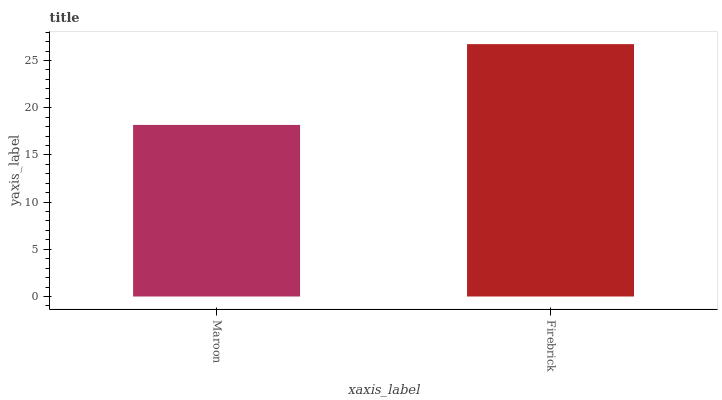Is Maroon the minimum?
Answer yes or no. Yes. Is Firebrick the maximum?
Answer yes or no. Yes. Is Firebrick the minimum?
Answer yes or no. No. Is Firebrick greater than Maroon?
Answer yes or no. Yes. Is Maroon less than Firebrick?
Answer yes or no. Yes. Is Maroon greater than Firebrick?
Answer yes or no. No. Is Firebrick less than Maroon?
Answer yes or no. No. Is Firebrick the high median?
Answer yes or no. Yes. Is Maroon the low median?
Answer yes or no. Yes. Is Maroon the high median?
Answer yes or no. No. Is Firebrick the low median?
Answer yes or no. No. 